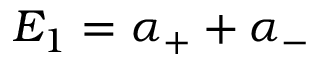<formula> <loc_0><loc_0><loc_500><loc_500>E _ { 1 } = \alpha _ { + } + \alpha _ { - }</formula> 